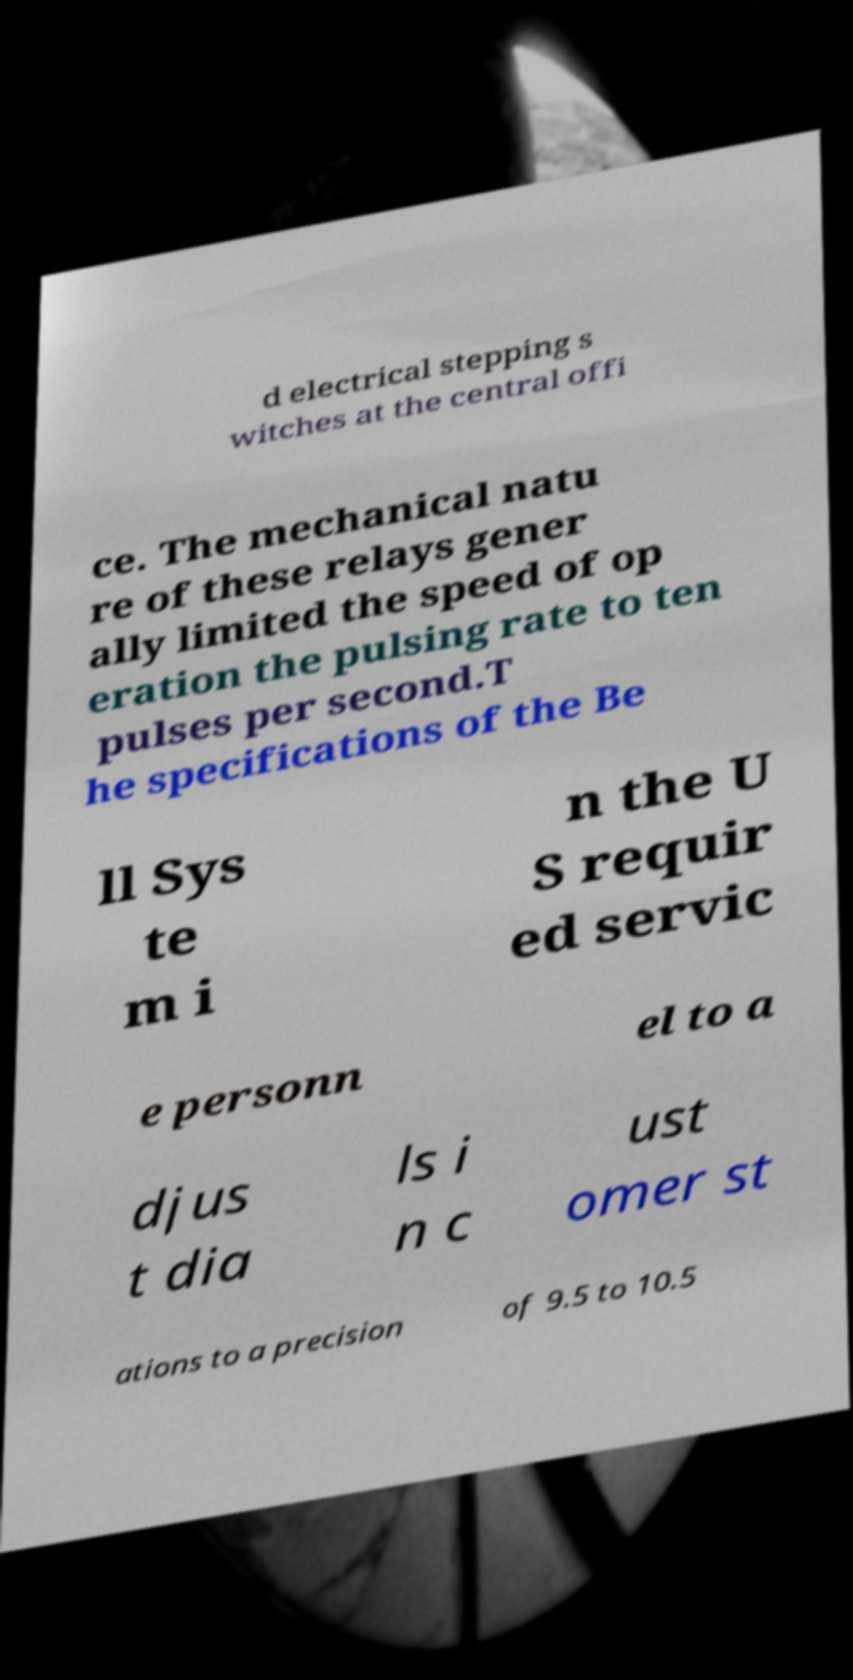What messages or text are displayed in this image? I need them in a readable, typed format. d electrical stepping s witches at the central offi ce. The mechanical natu re of these relays gener ally limited the speed of op eration the pulsing rate to ten pulses per second.T he specifications of the Be ll Sys te m i n the U S requir ed servic e personn el to a djus t dia ls i n c ust omer st ations to a precision of 9.5 to 10.5 